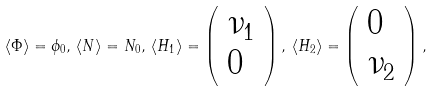<formula> <loc_0><loc_0><loc_500><loc_500>\langle \Phi \rangle = \phi _ { 0 } , \, \langle N \rangle = N _ { 0 } , \, \langle H _ { 1 } \rangle = \left ( \begin{array} { l } { { \nu _ { 1 } } } \\ { 0 } \end{array} \right ) , \, \langle H _ { 2 } \rangle = \left ( \begin{array} { l } { 0 } \\ { { \nu _ { 2 } } } \end{array} \right ) ,</formula> 